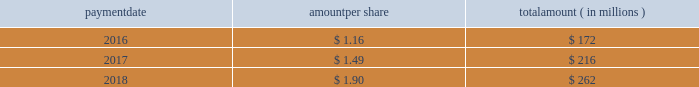Humana inc .
Notes to consolidated financial statements 2014 ( continued ) 15 .
Stockholders 2019 equity dividends the table provides details of dividend payments , excluding dividend equivalent rights , in 2016 , 2017 , and 2018 under our board approved quarterly cash dividend policy : payment amount per share amount ( in millions ) .
On november 2 , 2018 , the board declared a cash dividend of $ 0.50 per share that was paid on january 25 , 2019 to stockholders of record on december 31 , 2018 , for an aggregate amount of $ 68 million .
Declaration and payment of future quarterly dividends is at the discretion of our board and may be adjusted as business needs or market conditions change .
In february 2019 , the board declared a cash dividend of $ 0.55 per share payable on april 26 , 2019 to stockholders of record on march 29 , 2019 .
Stock repurchases our board of directors may authorize the purchase of our common shares .
Under our share repurchase authorization , shares may have been purchased from time to time at prevailing prices in the open market , by block purchases , through plans designed to comply with rule 10b5-1 under the securities exchange act of 1934 , as amended , or in privately-negotiated transactions ( including pursuant to accelerated share repurchase agreements with investment banks ) , subject to certain regulatory restrictions on volume , pricing , and timing .
On february 14 , 2017 , our board of directors authorized the repurchase of up to $ 2.25 billion of our common shares expiring on december 31 , 2017 , exclusive of shares repurchased in connection with employee stock plans .
On february 16 , 2017 , we entered into an accelerated share repurchase agreement , the february 2017 asr , with goldman , sachs & co .
Llc , or goldman sachs , to repurchase $ 1.5 billion of our common stock as part of the $ 2.25 billion share repurchase authorized on february 14 , 2017 .
On february 22 , 2017 , we made a payment of $ 1.5 billion to goldman sachs from available cash on hand and received an initial delivery of 5.83 million shares of our common stock from goldman sachs based on the then current market price of humana common stock .
The payment to goldman sachs was recorded as a reduction to stockholders 2019 equity , consisting of a $ 1.2 billion increase in treasury stock , which reflected the value of the initial 5.83 million shares received upon initial settlement , and a $ 300 million decrease in capital in excess of par value , which reflected the value of stock held back by goldman sachs pending final settlement of the february 2017 asr .
Upon settlement of the february 2017 asr on august 28 , 2017 , we received an additional 0.84 million shares as determined by the average daily volume weighted-average share price of our common stock during the term of the agreement of $ 224.81 , less a discount and subject to adjustments pursuant to the terms and conditions of the february 2017 asr , bringing the total shares received under this program to 6.67 million .
In addition , upon settlement we reclassified the $ 300 million value of stock initially held back by goldman sachs from capital in excess of par value to treasury stock .
Subsequent to settlement of the february 2017 asr , we repurchased an additional 3.04 million shares in the open market , utilizing the remaining $ 750 million of the $ 2.25 billion authorization prior to expiration .
On december 14 , 2017 , our board of directors authorized the repurchase of up to $ 3.0 billion of our common shares expiring on december 31 , 2020 , exclusive of shares repurchased in connection with employee stock plans. .
On november 2 , 2018 , what was the amount of shares in millions used the calculation of the total dividend payout? 
Rationale: on november 2 , 2018 , there was 136 million shares used the calculation of the total dividend payout
Computations: (68 / 0.50)
Answer: 136.0. 